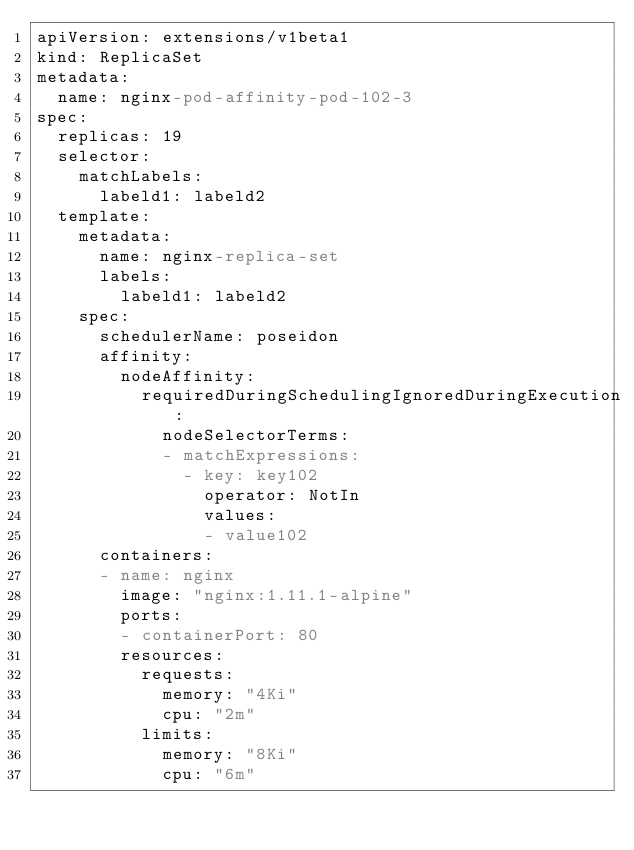<code> <loc_0><loc_0><loc_500><loc_500><_YAML_>apiVersion: extensions/v1beta1
kind: ReplicaSet
metadata:
  name: nginx-pod-affinity-pod-102-3
spec:
  replicas: 19
  selector:
    matchLabels:
      labeld1: labeld2
  template:
    metadata:
      name: nginx-replica-set
      labels:
        labeld1: labeld2
    spec:
      schedulerName: poseidon
      affinity:
        nodeAffinity:
          requiredDuringSchedulingIgnoredDuringExecution:
            nodeSelectorTerms:
            - matchExpressions:
              - key: key102
                operator: NotIn
                values:
                - value102
      containers:
      - name: nginx
        image: "nginx:1.11.1-alpine"
        ports:
        - containerPort: 80
        resources:
          requests:
            memory: "4Ki"
            cpu: "2m"
          limits:
            memory: "8Ki"
            cpu: "6m"
</code> 